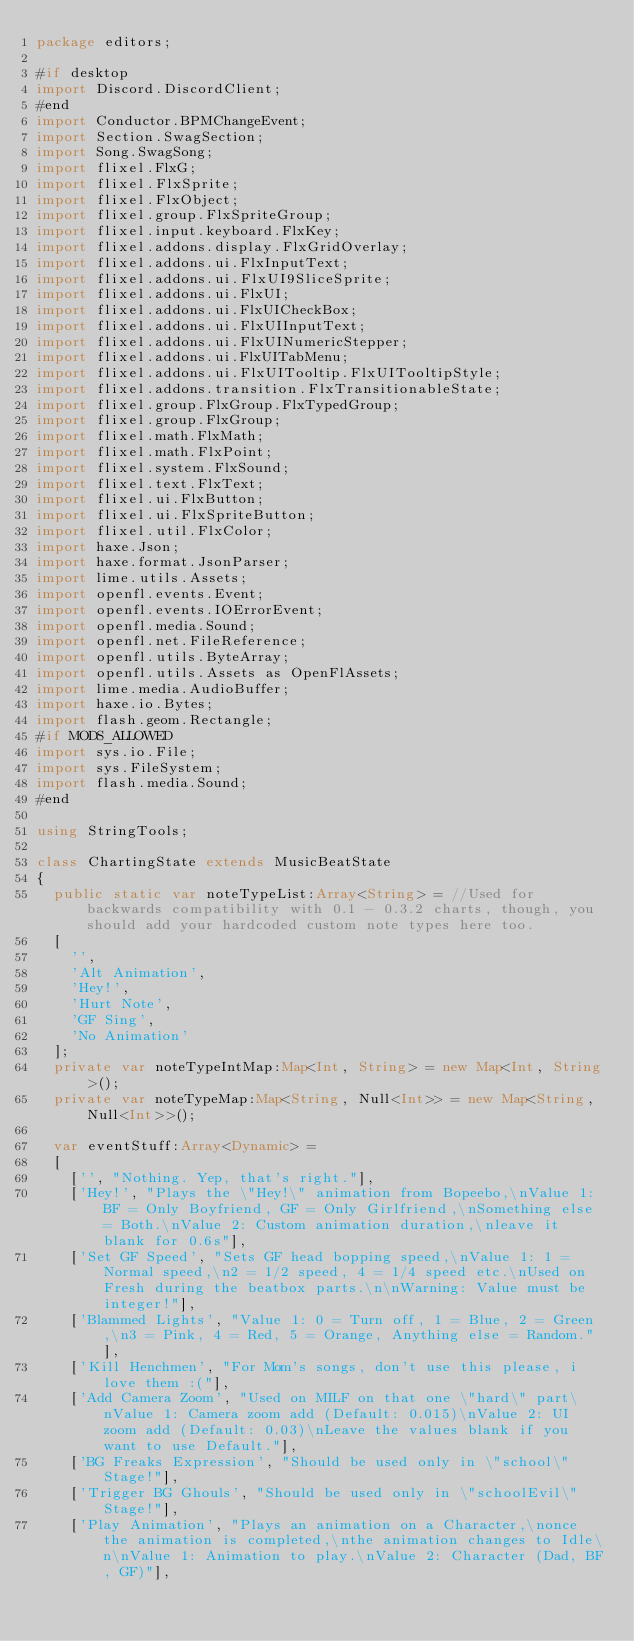Convert code to text. <code><loc_0><loc_0><loc_500><loc_500><_Haxe_>package editors;

#if desktop
import Discord.DiscordClient;
#end
import Conductor.BPMChangeEvent;
import Section.SwagSection;
import Song.SwagSong;
import flixel.FlxG;
import flixel.FlxSprite;
import flixel.FlxObject;
import flixel.group.FlxSpriteGroup;
import flixel.input.keyboard.FlxKey;
import flixel.addons.display.FlxGridOverlay;
import flixel.addons.ui.FlxInputText;
import flixel.addons.ui.FlxUI9SliceSprite;
import flixel.addons.ui.FlxUI;
import flixel.addons.ui.FlxUICheckBox;
import flixel.addons.ui.FlxUIInputText;
import flixel.addons.ui.FlxUINumericStepper;
import flixel.addons.ui.FlxUITabMenu;
import flixel.addons.ui.FlxUITooltip.FlxUITooltipStyle;
import flixel.addons.transition.FlxTransitionableState;
import flixel.group.FlxGroup.FlxTypedGroup;
import flixel.group.FlxGroup;
import flixel.math.FlxMath;
import flixel.math.FlxPoint;
import flixel.system.FlxSound;
import flixel.text.FlxText;
import flixel.ui.FlxButton;
import flixel.ui.FlxSpriteButton;
import flixel.util.FlxColor;
import haxe.Json;
import haxe.format.JsonParser;
import lime.utils.Assets;
import openfl.events.Event;
import openfl.events.IOErrorEvent;
import openfl.media.Sound;
import openfl.net.FileReference;
import openfl.utils.ByteArray;
import openfl.utils.Assets as OpenFlAssets;
import lime.media.AudioBuffer;
import haxe.io.Bytes;
import flash.geom.Rectangle;
#if MODS_ALLOWED
import sys.io.File;
import sys.FileSystem;
import flash.media.Sound;
#end

using StringTools;

class ChartingState extends MusicBeatState
{
	public static var noteTypeList:Array<String> = //Used for backwards compatibility with 0.1 - 0.3.2 charts, though, you should add your hardcoded custom note types here too.
	[
		'',
		'Alt Animation',
		'Hey!',
		'Hurt Note',
		'GF Sing',
		'No Animation'
	];
	private var noteTypeIntMap:Map<Int, String> = new Map<Int, String>();
	private var noteTypeMap:Map<String, Null<Int>> = new Map<String, Null<Int>>();

	var eventStuff:Array<Dynamic> =
	[
		['', "Nothing. Yep, that's right."],
		['Hey!', "Plays the \"Hey!\" animation from Bopeebo,\nValue 1: BF = Only Boyfriend, GF = Only Girlfriend,\nSomething else = Both.\nValue 2: Custom animation duration,\nleave it blank for 0.6s"],
		['Set GF Speed', "Sets GF head bopping speed,\nValue 1: 1 = Normal speed,\n2 = 1/2 speed, 4 = 1/4 speed etc.\nUsed on Fresh during the beatbox parts.\n\nWarning: Value must be integer!"],
		['Blammed Lights', "Value 1: 0 = Turn off, 1 = Blue, 2 = Green,\n3 = Pink, 4 = Red, 5 = Orange, Anything else = Random."],
		['Kill Henchmen', "For Mom's songs, don't use this please, i love them :("],
		['Add Camera Zoom', "Used on MILF on that one \"hard\" part\nValue 1: Camera zoom add (Default: 0.015)\nValue 2: UI zoom add (Default: 0.03)\nLeave the values blank if you want to use Default."],
		['BG Freaks Expression', "Should be used only in \"school\" Stage!"],
		['Trigger BG Ghouls', "Should be used only in \"schoolEvil\" Stage!"],
		['Play Animation', "Plays an animation on a Character,\nonce the animation is completed,\nthe animation changes to Idle\n\nValue 1: Animation to play.\nValue 2: Character (Dad, BF, GF)"],</code> 